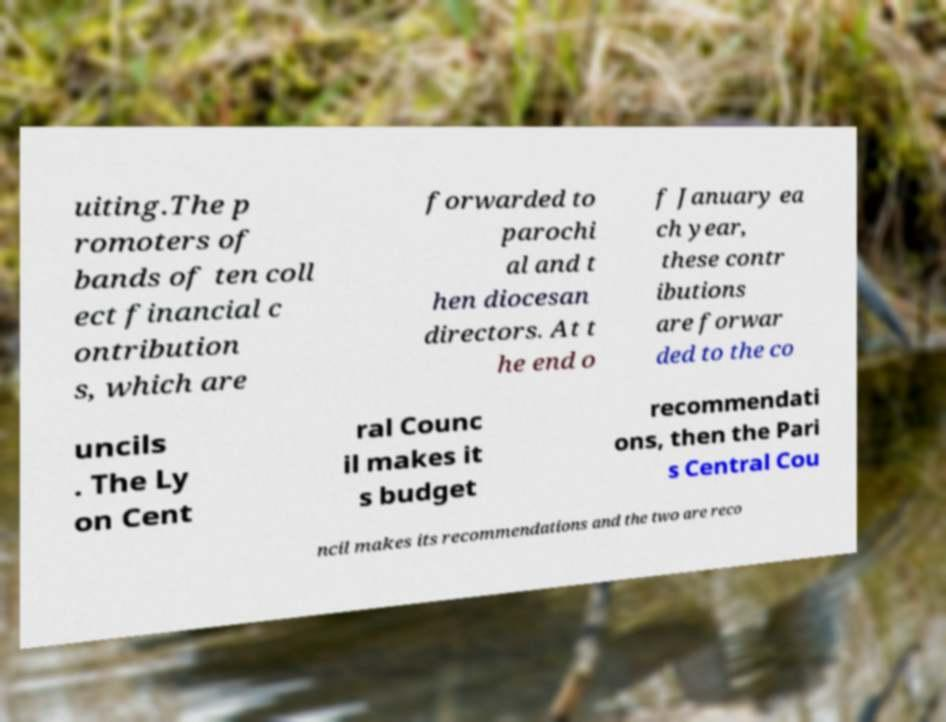Could you extract and type out the text from this image? uiting.The p romoters of bands of ten coll ect financial c ontribution s, which are forwarded to parochi al and t hen diocesan directors. At t he end o f January ea ch year, these contr ibutions are forwar ded to the co uncils . The Ly on Cent ral Counc il makes it s budget recommendati ons, then the Pari s Central Cou ncil makes its recommendations and the two are reco 